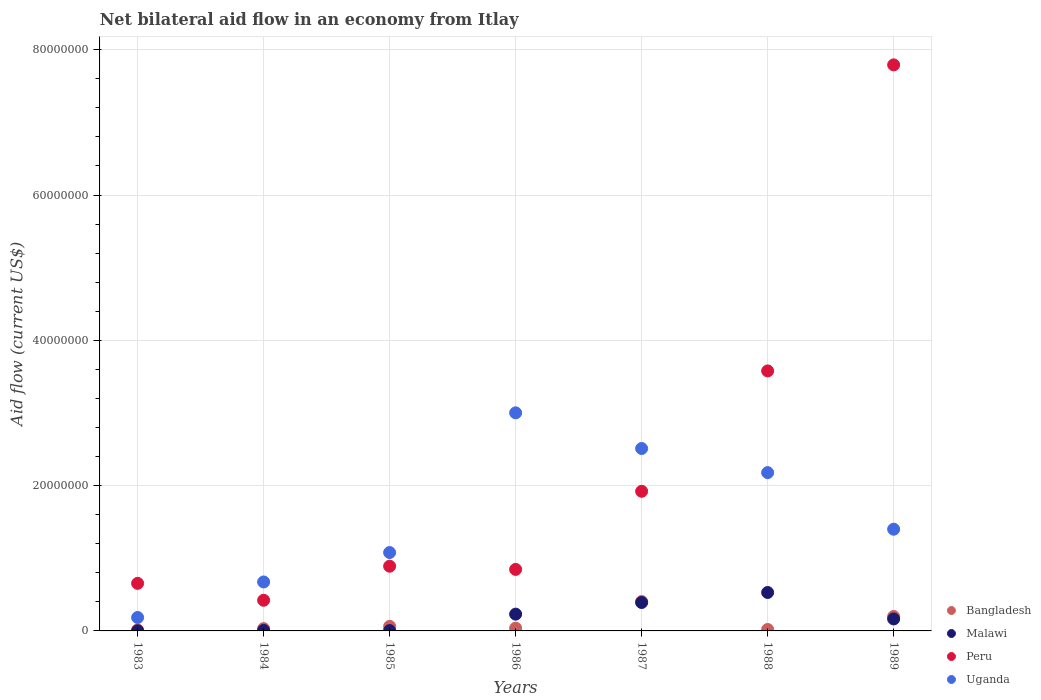How many different coloured dotlines are there?
Offer a very short reply. 4. Is the number of dotlines equal to the number of legend labels?
Make the answer very short. Yes. What is the net bilateral aid flow in Peru in 1987?
Offer a very short reply. 1.92e+07. Across all years, what is the maximum net bilateral aid flow in Malawi?
Ensure brevity in your answer.  5.29e+06. Across all years, what is the minimum net bilateral aid flow in Uganda?
Your answer should be compact. 1.85e+06. In which year was the net bilateral aid flow in Peru maximum?
Your answer should be compact. 1989. In which year was the net bilateral aid flow in Peru minimum?
Your answer should be compact. 1984. What is the total net bilateral aid flow in Uganda in the graph?
Your answer should be compact. 1.10e+08. What is the difference between the net bilateral aid flow in Malawi in 1983 and that in 1984?
Make the answer very short. -5.00e+04. What is the difference between the net bilateral aid flow in Peru in 1985 and the net bilateral aid flow in Bangladesh in 1987?
Your answer should be compact. 4.86e+06. What is the average net bilateral aid flow in Malawi per year?
Your response must be concise. 1.90e+06. In the year 1989, what is the difference between the net bilateral aid flow in Bangladesh and net bilateral aid flow in Malawi?
Your response must be concise. 3.40e+05. In how many years, is the net bilateral aid flow in Bangladesh greater than 56000000 US$?
Your answer should be very brief. 0. What is the ratio of the net bilateral aid flow in Bangladesh in 1985 to that in 1988?
Ensure brevity in your answer.  3.15. Is the difference between the net bilateral aid flow in Bangladesh in 1983 and 1987 greater than the difference between the net bilateral aid flow in Malawi in 1983 and 1987?
Offer a very short reply. No. What is the difference between the highest and the second highest net bilateral aid flow in Peru?
Offer a terse response. 4.21e+07. What is the difference between the highest and the lowest net bilateral aid flow in Malawi?
Offer a terse response. 5.27e+06. In how many years, is the net bilateral aid flow in Bangladesh greater than the average net bilateral aid flow in Bangladesh taken over all years?
Provide a succinct answer. 2. Is the sum of the net bilateral aid flow in Malawi in 1984 and 1985 greater than the maximum net bilateral aid flow in Bangladesh across all years?
Your answer should be very brief. No. Is it the case that in every year, the sum of the net bilateral aid flow in Malawi and net bilateral aid flow in Uganda  is greater than the net bilateral aid flow in Peru?
Your answer should be compact. No. Is the net bilateral aid flow in Bangladesh strictly greater than the net bilateral aid flow in Malawi over the years?
Provide a succinct answer. No. How many dotlines are there?
Offer a very short reply. 4. What is the difference between two consecutive major ticks on the Y-axis?
Offer a very short reply. 2.00e+07. Are the values on the major ticks of Y-axis written in scientific E-notation?
Offer a terse response. No. Does the graph contain grids?
Keep it short and to the point. Yes. How many legend labels are there?
Offer a very short reply. 4. How are the legend labels stacked?
Ensure brevity in your answer.  Vertical. What is the title of the graph?
Provide a succinct answer. Net bilateral aid flow in an economy from Itlay. Does "St. Vincent and the Grenadines" appear as one of the legend labels in the graph?
Provide a succinct answer. No. What is the label or title of the X-axis?
Your response must be concise. Years. What is the Aid flow (current US$) in Malawi in 1983?
Provide a short and direct response. 2.00e+04. What is the Aid flow (current US$) of Peru in 1983?
Your response must be concise. 6.55e+06. What is the Aid flow (current US$) in Uganda in 1983?
Your response must be concise. 1.85e+06. What is the Aid flow (current US$) of Bangladesh in 1984?
Offer a terse response. 3.20e+05. What is the Aid flow (current US$) of Peru in 1984?
Give a very brief answer. 4.22e+06. What is the Aid flow (current US$) in Uganda in 1984?
Ensure brevity in your answer.  6.74e+06. What is the Aid flow (current US$) of Bangladesh in 1985?
Offer a terse response. 6.30e+05. What is the Aid flow (current US$) in Peru in 1985?
Your answer should be very brief. 8.91e+06. What is the Aid flow (current US$) in Uganda in 1985?
Your answer should be very brief. 1.08e+07. What is the Aid flow (current US$) of Malawi in 1986?
Offer a very short reply. 2.31e+06. What is the Aid flow (current US$) of Peru in 1986?
Your answer should be very brief. 8.47e+06. What is the Aid flow (current US$) of Uganda in 1986?
Give a very brief answer. 3.00e+07. What is the Aid flow (current US$) of Bangladesh in 1987?
Give a very brief answer. 4.05e+06. What is the Aid flow (current US$) of Malawi in 1987?
Offer a very short reply. 3.91e+06. What is the Aid flow (current US$) of Peru in 1987?
Offer a terse response. 1.92e+07. What is the Aid flow (current US$) in Uganda in 1987?
Offer a terse response. 2.51e+07. What is the Aid flow (current US$) in Bangladesh in 1988?
Ensure brevity in your answer.  2.00e+05. What is the Aid flow (current US$) in Malawi in 1988?
Your answer should be compact. 5.29e+06. What is the Aid flow (current US$) of Peru in 1988?
Provide a succinct answer. 3.58e+07. What is the Aid flow (current US$) of Uganda in 1988?
Keep it short and to the point. 2.18e+07. What is the Aid flow (current US$) of Bangladesh in 1989?
Offer a very short reply. 1.99e+06. What is the Aid flow (current US$) in Malawi in 1989?
Provide a succinct answer. 1.65e+06. What is the Aid flow (current US$) in Peru in 1989?
Offer a terse response. 7.79e+07. What is the Aid flow (current US$) of Uganda in 1989?
Provide a succinct answer. 1.40e+07. Across all years, what is the maximum Aid flow (current US$) of Bangladesh?
Provide a succinct answer. 4.05e+06. Across all years, what is the maximum Aid flow (current US$) of Malawi?
Make the answer very short. 5.29e+06. Across all years, what is the maximum Aid flow (current US$) of Peru?
Offer a terse response. 7.79e+07. Across all years, what is the maximum Aid flow (current US$) of Uganda?
Your answer should be compact. 3.00e+07. Across all years, what is the minimum Aid flow (current US$) in Bangladesh?
Provide a succinct answer. 1.30e+05. Across all years, what is the minimum Aid flow (current US$) in Malawi?
Offer a terse response. 2.00e+04. Across all years, what is the minimum Aid flow (current US$) in Peru?
Offer a very short reply. 4.22e+06. Across all years, what is the minimum Aid flow (current US$) of Uganda?
Make the answer very short. 1.85e+06. What is the total Aid flow (current US$) in Bangladesh in the graph?
Ensure brevity in your answer.  7.70e+06. What is the total Aid flow (current US$) in Malawi in the graph?
Your response must be concise. 1.33e+07. What is the total Aid flow (current US$) in Peru in the graph?
Offer a very short reply. 1.61e+08. What is the total Aid flow (current US$) of Uganda in the graph?
Provide a succinct answer. 1.10e+08. What is the difference between the Aid flow (current US$) in Bangladesh in 1983 and that in 1984?
Keep it short and to the point. -1.90e+05. What is the difference between the Aid flow (current US$) in Malawi in 1983 and that in 1984?
Your response must be concise. -5.00e+04. What is the difference between the Aid flow (current US$) of Peru in 1983 and that in 1984?
Provide a succinct answer. 2.33e+06. What is the difference between the Aid flow (current US$) in Uganda in 1983 and that in 1984?
Offer a terse response. -4.89e+06. What is the difference between the Aid flow (current US$) in Bangladesh in 1983 and that in 1985?
Make the answer very short. -5.00e+05. What is the difference between the Aid flow (current US$) in Peru in 1983 and that in 1985?
Offer a terse response. -2.36e+06. What is the difference between the Aid flow (current US$) in Uganda in 1983 and that in 1985?
Provide a succinct answer. -8.94e+06. What is the difference between the Aid flow (current US$) in Malawi in 1983 and that in 1986?
Give a very brief answer. -2.29e+06. What is the difference between the Aid flow (current US$) in Peru in 1983 and that in 1986?
Provide a short and direct response. -1.92e+06. What is the difference between the Aid flow (current US$) in Uganda in 1983 and that in 1986?
Give a very brief answer. -2.82e+07. What is the difference between the Aid flow (current US$) in Bangladesh in 1983 and that in 1987?
Ensure brevity in your answer.  -3.92e+06. What is the difference between the Aid flow (current US$) of Malawi in 1983 and that in 1987?
Offer a very short reply. -3.89e+06. What is the difference between the Aid flow (current US$) of Peru in 1983 and that in 1987?
Offer a very short reply. -1.27e+07. What is the difference between the Aid flow (current US$) of Uganda in 1983 and that in 1987?
Your answer should be compact. -2.33e+07. What is the difference between the Aid flow (current US$) in Bangladesh in 1983 and that in 1988?
Provide a short and direct response. -7.00e+04. What is the difference between the Aid flow (current US$) in Malawi in 1983 and that in 1988?
Provide a short and direct response. -5.27e+06. What is the difference between the Aid flow (current US$) in Peru in 1983 and that in 1988?
Provide a succinct answer. -2.92e+07. What is the difference between the Aid flow (current US$) in Uganda in 1983 and that in 1988?
Offer a terse response. -1.99e+07. What is the difference between the Aid flow (current US$) of Bangladesh in 1983 and that in 1989?
Your response must be concise. -1.86e+06. What is the difference between the Aid flow (current US$) of Malawi in 1983 and that in 1989?
Provide a short and direct response. -1.63e+06. What is the difference between the Aid flow (current US$) of Peru in 1983 and that in 1989?
Ensure brevity in your answer.  -7.14e+07. What is the difference between the Aid flow (current US$) in Uganda in 1983 and that in 1989?
Make the answer very short. -1.22e+07. What is the difference between the Aid flow (current US$) in Bangladesh in 1984 and that in 1985?
Your answer should be compact. -3.10e+05. What is the difference between the Aid flow (current US$) in Peru in 1984 and that in 1985?
Keep it short and to the point. -4.69e+06. What is the difference between the Aid flow (current US$) in Uganda in 1984 and that in 1985?
Your answer should be compact. -4.05e+06. What is the difference between the Aid flow (current US$) in Bangladesh in 1984 and that in 1986?
Offer a very short reply. -6.00e+04. What is the difference between the Aid flow (current US$) in Malawi in 1984 and that in 1986?
Your answer should be very brief. -2.24e+06. What is the difference between the Aid flow (current US$) in Peru in 1984 and that in 1986?
Keep it short and to the point. -4.25e+06. What is the difference between the Aid flow (current US$) in Uganda in 1984 and that in 1986?
Offer a very short reply. -2.33e+07. What is the difference between the Aid flow (current US$) of Bangladesh in 1984 and that in 1987?
Your answer should be very brief. -3.73e+06. What is the difference between the Aid flow (current US$) of Malawi in 1984 and that in 1987?
Your answer should be compact. -3.84e+06. What is the difference between the Aid flow (current US$) of Peru in 1984 and that in 1987?
Give a very brief answer. -1.50e+07. What is the difference between the Aid flow (current US$) of Uganda in 1984 and that in 1987?
Provide a succinct answer. -1.84e+07. What is the difference between the Aid flow (current US$) in Malawi in 1984 and that in 1988?
Your response must be concise. -5.22e+06. What is the difference between the Aid flow (current US$) in Peru in 1984 and that in 1988?
Give a very brief answer. -3.16e+07. What is the difference between the Aid flow (current US$) in Uganda in 1984 and that in 1988?
Your answer should be very brief. -1.50e+07. What is the difference between the Aid flow (current US$) of Bangladesh in 1984 and that in 1989?
Make the answer very short. -1.67e+06. What is the difference between the Aid flow (current US$) in Malawi in 1984 and that in 1989?
Provide a short and direct response. -1.58e+06. What is the difference between the Aid flow (current US$) of Peru in 1984 and that in 1989?
Provide a short and direct response. -7.37e+07. What is the difference between the Aid flow (current US$) in Uganda in 1984 and that in 1989?
Provide a short and direct response. -7.26e+06. What is the difference between the Aid flow (current US$) of Malawi in 1985 and that in 1986?
Provide a succinct answer. -2.26e+06. What is the difference between the Aid flow (current US$) in Uganda in 1985 and that in 1986?
Provide a succinct answer. -1.92e+07. What is the difference between the Aid flow (current US$) in Bangladesh in 1985 and that in 1987?
Your answer should be compact. -3.42e+06. What is the difference between the Aid flow (current US$) in Malawi in 1985 and that in 1987?
Make the answer very short. -3.86e+06. What is the difference between the Aid flow (current US$) of Peru in 1985 and that in 1987?
Your answer should be very brief. -1.03e+07. What is the difference between the Aid flow (current US$) in Uganda in 1985 and that in 1987?
Offer a very short reply. -1.43e+07. What is the difference between the Aid flow (current US$) of Bangladesh in 1985 and that in 1988?
Provide a short and direct response. 4.30e+05. What is the difference between the Aid flow (current US$) of Malawi in 1985 and that in 1988?
Give a very brief answer. -5.24e+06. What is the difference between the Aid flow (current US$) in Peru in 1985 and that in 1988?
Provide a succinct answer. -2.69e+07. What is the difference between the Aid flow (current US$) in Uganda in 1985 and that in 1988?
Give a very brief answer. -1.10e+07. What is the difference between the Aid flow (current US$) in Bangladesh in 1985 and that in 1989?
Ensure brevity in your answer.  -1.36e+06. What is the difference between the Aid flow (current US$) of Malawi in 1985 and that in 1989?
Your response must be concise. -1.60e+06. What is the difference between the Aid flow (current US$) of Peru in 1985 and that in 1989?
Your response must be concise. -6.90e+07. What is the difference between the Aid flow (current US$) of Uganda in 1985 and that in 1989?
Provide a succinct answer. -3.21e+06. What is the difference between the Aid flow (current US$) of Bangladesh in 1986 and that in 1987?
Make the answer very short. -3.67e+06. What is the difference between the Aid flow (current US$) in Malawi in 1986 and that in 1987?
Ensure brevity in your answer.  -1.60e+06. What is the difference between the Aid flow (current US$) of Peru in 1986 and that in 1987?
Your answer should be very brief. -1.08e+07. What is the difference between the Aid flow (current US$) in Uganda in 1986 and that in 1987?
Ensure brevity in your answer.  4.91e+06. What is the difference between the Aid flow (current US$) of Malawi in 1986 and that in 1988?
Provide a short and direct response. -2.98e+06. What is the difference between the Aid flow (current US$) of Peru in 1986 and that in 1988?
Provide a short and direct response. -2.73e+07. What is the difference between the Aid flow (current US$) of Uganda in 1986 and that in 1988?
Provide a succinct answer. 8.23e+06. What is the difference between the Aid flow (current US$) of Bangladesh in 1986 and that in 1989?
Your response must be concise. -1.61e+06. What is the difference between the Aid flow (current US$) of Malawi in 1986 and that in 1989?
Make the answer very short. 6.60e+05. What is the difference between the Aid flow (current US$) in Peru in 1986 and that in 1989?
Your answer should be very brief. -6.94e+07. What is the difference between the Aid flow (current US$) in Uganda in 1986 and that in 1989?
Your answer should be compact. 1.60e+07. What is the difference between the Aid flow (current US$) in Bangladesh in 1987 and that in 1988?
Give a very brief answer. 3.85e+06. What is the difference between the Aid flow (current US$) of Malawi in 1987 and that in 1988?
Give a very brief answer. -1.38e+06. What is the difference between the Aid flow (current US$) of Peru in 1987 and that in 1988?
Keep it short and to the point. -1.66e+07. What is the difference between the Aid flow (current US$) in Uganda in 1987 and that in 1988?
Your response must be concise. 3.32e+06. What is the difference between the Aid flow (current US$) in Bangladesh in 1987 and that in 1989?
Offer a very short reply. 2.06e+06. What is the difference between the Aid flow (current US$) in Malawi in 1987 and that in 1989?
Your answer should be very brief. 2.26e+06. What is the difference between the Aid flow (current US$) in Peru in 1987 and that in 1989?
Your answer should be compact. -5.87e+07. What is the difference between the Aid flow (current US$) in Uganda in 1987 and that in 1989?
Keep it short and to the point. 1.11e+07. What is the difference between the Aid flow (current US$) in Bangladesh in 1988 and that in 1989?
Ensure brevity in your answer.  -1.79e+06. What is the difference between the Aid flow (current US$) of Malawi in 1988 and that in 1989?
Your response must be concise. 3.64e+06. What is the difference between the Aid flow (current US$) of Peru in 1988 and that in 1989?
Keep it short and to the point. -4.21e+07. What is the difference between the Aid flow (current US$) of Uganda in 1988 and that in 1989?
Provide a succinct answer. 7.79e+06. What is the difference between the Aid flow (current US$) of Bangladesh in 1983 and the Aid flow (current US$) of Peru in 1984?
Your response must be concise. -4.09e+06. What is the difference between the Aid flow (current US$) in Bangladesh in 1983 and the Aid flow (current US$) in Uganda in 1984?
Give a very brief answer. -6.61e+06. What is the difference between the Aid flow (current US$) in Malawi in 1983 and the Aid flow (current US$) in Peru in 1984?
Give a very brief answer. -4.20e+06. What is the difference between the Aid flow (current US$) of Malawi in 1983 and the Aid flow (current US$) of Uganda in 1984?
Make the answer very short. -6.72e+06. What is the difference between the Aid flow (current US$) in Bangladesh in 1983 and the Aid flow (current US$) in Peru in 1985?
Ensure brevity in your answer.  -8.78e+06. What is the difference between the Aid flow (current US$) of Bangladesh in 1983 and the Aid flow (current US$) of Uganda in 1985?
Provide a succinct answer. -1.07e+07. What is the difference between the Aid flow (current US$) of Malawi in 1983 and the Aid flow (current US$) of Peru in 1985?
Your answer should be compact. -8.89e+06. What is the difference between the Aid flow (current US$) of Malawi in 1983 and the Aid flow (current US$) of Uganda in 1985?
Your answer should be compact. -1.08e+07. What is the difference between the Aid flow (current US$) in Peru in 1983 and the Aid flow (current US$) in Uganda in 1985?
Your response must be concise. -4.24e+06. What is the difference between the Aid flow (current US$) in Bangladesh in 1983 and the Aid flow (current US$) in Malawi in 1986?
Provide a short and direct response. -2.18e+06. What is the difference between the Aid flow (current US$) in Bangladesh in 1983 and the Aid flow (current US$) in Peru in 1986?
Offer a very short reply. -8.34e+06. What is the difference between the Aid flow (current US$) of Bangladesh in 1983 and the Aid flow (current US$) of Uganda in 1986?
Your answer should be very brief. -2.99e+07. What is the difference between the Aid flow (current US$) of Malawi in 1983 and the Aid flow (current US$) of Peru in 1986?
Your response must be concise. -8.45e+06. What is the difference between the Aid flow (current US$) in Malawi in 1983 and the Aid flow (current US$) in Uganda in 1986?
Your answer should be very brief. -3.00e+07. What is the difference between the Aid flow (current US$) of Peru in 1983 and the Aid flow (current US$) of Uganda in 1986?
Ensure brevity in your answer.  -2.35e+07. What is the difference between the Aid flow (current US$) in Bangladesh in 1983 and the Aid flow (current US$) in Malawi in 1987?
Keep it short and to the point. -3.78e+06. What is the difference between the Aid flow (current US$) in Bangladesh in 1983 and the Aid flow (current US$) in Peru in 1987?
Give a very brief answer. -1.91e+07. What is the difference between the Aid flow (current US$) in Bangladesh in 1983 and the Aid flow (current US$) in Uganda in 1987?
Ensure brevity in your answer.  -2.50e+07. What is the difference between the Aid flow (current US$) of Malawi in 1983 and the Aid flow (current US$) of Peru in 1987?
Your answer should be compact. -1.92e+07. What is the difference between the Aid flow (current US$) of Malawi in 1983 and the Aid flow (current US$) of Uganda in 1987?
Offer a terse response. -2.51e+07. What is the difference between the Aid flow (current US$) in Peru in 1983 and the Aid flow (current US$) in Uganda in 1987?
Your response must be concise. -1.86e+07. What is the difference between the Aid flow (current US$) of Bangladesh in 1983 and the Aid flow (current US$) of Malawi in 1988?
Your answer should be compact. -5.16e+06. What is the difference between the Aid flow (current US$) in Bangladesh in 1983 and the Aid flow (current US$) in Peru in 1988?
Make the answer very short. -3.57e+07. What is the difference between the Aid flow (current US$) of Bangladesh in 1983 and the Aid flow (current US$) of Uganda in 1988?
Provide a succinct answer. -2.17e+07. What is the difference between the Aid flow (current US$) of Malawi in 1983 and the Aid flow (current US$) of Peru in 1988?
Keep it short and to the point. -3.58e+07. What is the difference between the Aid flow (current US$) in Malawi in 1983 and the Aid flow (current US$) in Uganda in 1988?
Your answer should be very brief. -2.18e+07. What is the difference between the Aid flow (current US$) in Peru in 1983 and the Aid flow (current US$) in Uganda in 1988?
Your answer should be compact. -1.52e+07. What is the difference between the Aid flow (current US$) in Bangladesh in 1983 and the Aid flow (current US$) in Malawi in 1989?
Offer a terse response. -1.52e+06. What is the difference between the Aid flow (current US$) of Bangladesh in 1983 and the Aid flow (current US$) of Peru in 1989?
Make the answer very short. -7.78e+07. What is the difference between the Aid flow (current US$) in Bangladesh in 1983 and the Aid flow (current US$) in Uganda in 1989?
Your answer should be very brief. -1.39e+07. What is the difference between the Aid flow (current US$) of Malawi in 1983 and the Aid flow (current US$) of Peru in 1989?
Your answer should be compact. -7.79e+07. What is the difference between the Aid flow (current US$) of Malawi in 1983 and the Aid flow (current US$) of Uganda in 1989?
Offer a very short reply. -1.40e+07. What is the difference between the Aid flow (current US$) of Peru in 1983 and the Aid flow (current US$) of Uganda in 1989?
Your answer should be very brief. -7.45e+06. What is the difference between the Aid flow (current US$) of Bangladesh in 1984 and the Aid flow (current US$) of Peru in 1985?
Provide a short and direct response. -8.59e+06. What is the difference between the Aid flow (current US$) in Bangladesh in 1984 and the Aid flow (current US$) in Uganda in 1985?
Offer a very short reply. -1.05e+07. What is the difference between the Aid flow (current US$) in Malawi in 1984 and the Aid flow (current US$) in Peru in 1985?
Your response must be concise. -8.84e+06. What is the difference between the Aid flow (current US$) of Malawi in 1984 and the Aid flow (current US$) of Uganda in 1985?
Provide a short and direct response. -1.07e+07. What is the difference between the Aid flow (current US$) of Peru in 1984 and the Aid flow (current US$) of Uganda in 1985?
Provide a short and direct response. -6.57e+06. What is the difference between the Aid flow (current US$) in Bangladesh in 1984 and the Aid flow (current US$) in Malawi in 1986?
Provide a succinct answer. -1.99e+06. What is the difference between the Aid flow (current US$) in Bangladesh in 1984 and the Aid flow (current US$) in Peru in 1986?
Your answer should be compact. -8.15e+06. What is the difference between the Aid flow (current US$) of Bangladesh in 1984 and the Aid flow (current US$) of Uganda in 1986?
Offer a terse response. -2.97e+07. What is the difference between the Aid flow (current US$) in Malawi in 1984 and the Aid flow (current US$) in Peru in 1986?
Give a very brief answer. -8.40e+06. What is the difference between the Aid flow (current US$) in Malawi in 1984 and the Aid flow (current US$) in Uganda in 1986?
Ensure brevity in your answer.  -3.00e+07. What is the difference between the Aid flow (current US$) in Peru in 1984 and the Aid flow (current US$) in Uganda in 1986?
Offer a terse response. -2.58e+07. What is the difference between the Aid flow (current US$) of Bangladesh in 1984 and the Aid flow (current US$) of Malawi in 1987?
Keep it short and to the point. -3.59e+06. What is the difference between the Aid flow (current US$) of Bangladesh in 1984 and the Aid flow (current US$) of Peru in 1987?
Keep it short and to the point. -1.89e+07. What is the difference between the Aid flow (current US$) in Bangladesh in 1984 and the Aid flow (current US$) in Uganda in 1987?
Your answer should be compact. -2.48e+07. What is the difference between the Aid flow (current US$) of Malawi in 1984 and the Aid flow (current US$) of Peru in 1987?
Ensure brevity in your answer.  -1.92e+07. What is the difference between the Aid flow (current US$) of Malawi in 1984 and the Aid flow (current US$) of Uganda in 1987?
Provide a succinct answer. -2.50e+07. What is the difference between the Aid flow (current US$) of Peru in 1984 and the Aid flow (current US$) of Uganda in 1987?
Your answer should be compact. -2.09e+07. What is the difference between the Aid flow (current US$) of Bangladesh in 1984 and the Aid flow (current US$) of Malawi in 1988?
Provide a succinct answer. -4.97e+06. What is the difference between the Aid flow (current US$) in Bangladesh in 1984 and the Aid flow (current US$) in Peru in 1988?
Offer a very short reply. -3.55e+07. What is the difference between the Aid flow (current US$) of Bangladesh in 1984 and the Aid flow (current US$) of Uganda in 1988?
Your response must be concise. -2.15e+07. What is the difference between the Aid flow (current US$) in Malawi in 1984 and the Aid flow (current US$) in Peru in 1988?
Offer a terse response. -3.57e+07. What is the difference between the Aid flow (current US$) of Malawi in 1984 and the Aid flow (current US$) of Uganda in 1988?
Your answer should be very brief. -2.17e+07. What is the difference between the Aid flow (current US$) of Peru in 1984 and the Aid flow (current US$) of Uganda in 1988?
Your response must be concise. -1.76e+07. What is the difference between the Aid flow (current US$) in Bangladesh in 1984 and the Aid flow (current US$) in Malawi in 1989?
Give a very brief answer. -1.33e+06. What is the difference between the Aid flow (current US$) of Bangladesh in 1984 and the Aid flow (current US$) of Peru in 1989?
Provide a short and direct response. -7.76e+07. What is the difference between the Aid flow (current US$) in Bangladesh in 1984 and the Aid flow (current US$) in Uganda in 1989?
Offer a very short reply. -1.37e+07. What is the difference between the Aid flow (current US$) of Malawi in 1984 and the Aid flow (current US$) of Peru in 1989?
Your answer should be compact. -7.78e+07. What is the difference between the Aid flow (current US$) of Malawi in 1984 and the Aid flow (current US$) of Uganda in 1989?
Provide a short and direct response. -1.39e+07. What is the difference between the Aid flow (current US$) in Peru in 1984 and the Aid flow (current US$) in Uganda in 1989?
Make the answer very short. -9.78e+06. What is the difference between the Aid flow (current US$) of Bangladesh in 1985 and the Aid flow (current US$) of Malawi in 1986?
Offer a very short reply. -1.68e+06. What is the difference between the Aid flow (current US$) in Bangladesh in 1985 and the Aid flow (current US$) in Peru in 1986?
Your answer should be compact. -7.84e+06. What is the difference between the Aid flow (current US$) in Bangladesh in 1985 and the Aid flow (current US$) in Uganda in 1986?
Keep it short and to the point. -2.94e+07. What is the difference between the Aid flow (current US$) of Malawi in 1985 and the Aid flow (current US$) of Peru in 1986?
Make the answer very short. -8.42e+06. What is the difference between the Aid flow (current US$) in Malawi in 1985 and the Aid flow (current US$) in Uganda in 1986?
Your answer should be very brief. -3.00e+07. What is the difference between the Aid flow (current US$) in Peru in 1985 and the Aid flow (current US$) in Uganda in 1986?
Your answer should be compact. -2.11e+07. What is the difference between the Aid flow (current US$) of Bangladesh in 1985 and the Aid flow (current US$) of Malawi in 1987?
Ensure brevity in your answer.  -3.28e+06. What is the difference between the Aid flow (current US$) in Bangladesh in 1985 and the Aid flow (current US$) in Peru in 1987?
Offer a very short reply. -1.86e+07. What is the difference between the Aid flow (current US$) in Bangladesh in 1985 and the Aid flow (current US$) in Uganda in 1987?
Your response must be concise. -2.45e+07. What is the difference between the Aid flow (current US$) of Malawi in 1985 and the Aid flow (current US$) of Peru in 1987?
Provide a succinct answer. -1.92e+07. What is the difference between the Aid flow (current US$) in Malawi in 1985 and the Aid flow (current US$) in Uganda in 1987?
Provide a short and direct response. -2.51e+07. What is the difference between the Aid flow (current US$) of Peru in 1985 and the Aid flow (current US$) of Uganda in 1987?
Ensure brevity in your answer.  -1.62e+07. What is the difference between the Aid flow (current US$) in Bangladesh in 1985 and the Aid flow (current US$) in Malawi in 1988?
Keep it short and to the point. -4.66e+06. What is the difference between the Aid flow (current US$) in Bangladesh in 1985 and the Aid flow (current US$) in Peru in 1988?
Offer a terse response. -3.52e+07. What is the difference between the Aid flow (current US$) in Bangladesh in 1985 and the Aid flow (current US$) in Uganda in 1988?
Your answer should be compact. -2.12e+07. What is the difference between the Aid flow (current US$) of Malawi in 1985 and the Aid flow (current US$) of Peru in 1988?
Your answer should be very brief. -3.57e+07. What is the difference between the Aid flow (current US$) in Malawi in 1985 and the Aid flow (current US$) in Uganda in 1988?
Offer a terse response. -2.17e+07. What is the difference between the Aid flow (current US$) of Peru in 1985 and the Aid flow (current US$) of Uganda in 1988?
Keep it short and to the point. -1.29e+07. What is the difference between the Aid flow (current US$) in Bangladesh in 1985 and the Aid flow (current US$) in Malawi in 1989?
Offer a very short reply. -1.02e+06. What is the difference between the Aid flow (current US$) in Bangladesh in 1985 and the Aid flow (current US$) in Peru in 1989?
Provide a short and direct response. -7.73e+07. What is the difference between the Aid flow (current US$) in Bangladesh in 1985 and the Aid flow (current US$) in Uganda in 1989?
Make the answer very short. -1.34e+07. What is the difference between the Aid flow (current US$) of Malawi in 1985 and the Aid flow (current US$) of Peru in 1989?
Provide a succinct answer. -7.79e+07. What is the difference between the Aid flow (current US$) in Malawi in 1985 and the Aid flow (current US$) in Uganda in 1989?
Offer a terse response. -1.40e+07. What is the difference between the Aid flow (current US$) of Peru in 1985 and the Aid flow (current US$) of Uganda in 1989?
Provide a succinct answer. -5.09e+06. What is the difference between the Aid flow (current US$) of Bangladesh in 1986 and the Aid flow (current US$) of Malawi in 1987?
Provide a short and direct response. -3.53e+06. What is the difference between the Aid flow (current US$) of Bangladesh in 1986 and the Aid flow (current US$) of Peru in 1987?
Provide a short and direct response. -1.88e+07. What is the difference between the Aid flow (current US$) in Bangladesh in 1986 and the Aid flow (current US$) in Uganda in 1987?
Your answer should be compact. -2.47e+07. What is the difference between the Aid flow (current US$) in Malawi in 1986 and the Aid flow (current US$) in Peru in 1987?
Offer a very short reply. -1.69e+07. What is the difference between the Aid flow (current US$) of Malawi in 1986 and the Aid flow (current US$) of Uganda in 1987?
Make the answer very short. -2.28e+07. What is the difference between the Aid flow (current US$) of Peru in 1986 and the Aid flow (current US$) of Uganda in 1987?
Offer a very short reply. -1.66e+07. What is the difference between the Aid flow (current US$) of Bangladesh in 1986 and the Aid flow (current US$) of Malawi in 1988?
Keep it short and to the point. -4.91e+06. What is the difference between the Aid flow (current US$) of Bangladesh in 1986 and the Aid flow (current US$) of Peru in 1988?
Ensure brevity in your answer.  -3.54e+07. What is the difference between the Aid flow (current US$) of Bangladesh in 1986 and the Aid flow (current US$) of Uganda in 1988?
Give a very brief answer. -2.14e+07. What is the difference between the Aid flow (current US$) in Malawi in 1986 and the Aid flow (current US$) in Peru in 1988?
Your response must be concise. -3.35e+07. What is the difference between the Aid flow (current US$) in Malawi in 1986 and the Aid flow (current US$) in Uganda in 1988?
Your response must be concise. -1.95e+07. What is the difference between the Aid flow (current US$) of Peru in 1986 and the Aid flow (current US$) of Uganda in 1988?
Ensure brevity in your answer.  -1.33e+07. What is the difference between the Aid flow (current US$) in Bangladesh in 1986 and the Aid flow (current US$) in Malawi in 1989?
Ensure brevity in your answer.  -1.27e+06. What is the difference between the Aid flow (current US$) of Bangladesh in 1986 and the Aid flow (current US$) of Peru in 1989?
Your answer should be compact. -7.75e+07. What is the difference between the Aid flow (current US$) of Bangladesh in 1986 and the Aid flow (current US$) of Uganda in 1989?
Offer a terse response. -1.36e+07. What is the difference between the Aid flow (current US$) in Malawi in 1986 and the Aid flow (current US$) in Peru in 1989?
Provide a succinct answer. -7.56e+07. What is the difference between the Aid flow (current US$) of Malawi in 1986 and the Aid flow (current US$) of Uganda in 1989?
Provide a short and direct response. -1.17e+07. What is the difference between the Aid flow (current US$) in Peru in 1986 and the Aid flow (current US$) in Uganda in 1989?
Offer a very short reply. -5.53e+06. What is the difference between the Aid flow (current US$) of Bangladesh in 1987 and the Aid flow (current US$) of Malawi in 1988?
Offer a terse response. -1.24e+06. What is the difference between the Aid flow (current US$) in Bangladesh in 1987 and the Aid flow (current US$) in Peru in 1988?
Your answer should be compact. -3.17e+07. What is the difference between the Aid flow (current US$) of Bangladesh in 1987 and the Aid flow (current US$) of Uganda in 1988?
Give a very brief answer. -1.77e+07. What is the difference between the Aid flow (current US$) in Malawi in 1987 and the Aid flow (current US$) in Peru in 1988?
Your answer should be very brief. -3.19e+07. What is the difference between the Aid flow (current US$) of Malawi in 1987 and the Aid flow (current US$) of Uganda in 1988?
Keep it short and to the point. -1.79e+07. What is the difference between the Aid flow (current US$) of Peru in 1987 and the Aid flow (current US$) of Uganda in 1988?
Provide a short and direct response. -2.57e+06. What is the difference between the Aid flow (current US$) of Bangladesh in 1987 and the Aid flow (current US$) of Malawi in 1989?
Give a very brief answer. 2.40e+06. What is the difference between the Aid flow (current US$) of Bangladesh in 1987 and the Aid flow (current US$) of Peru in 1989?
Your answer should be compact. -7.39e+07. What is the difference between the Aid flow (current US$) in Bangladesh in 1987 and the Aid flow (current US$) in Uganda in 1989?
Your answer should be compact. -9.95e+06. What is the difference between the Aid flow (current US$) of Malawi in 1987 and the Aid flow (current US$) of Peru in 1989?
Offer a very short reply. -7.40e+07. What is the difference between the Aid flow (current US$) in Malawi in 1987 and the Aid flow (current US$) in Uganda in 1989?
Your answer should be compact. -1.01e+07. What is the difference between the Aid flow (current US$) in Peru in 1987 and the Aid flow (current US$) in Uganda in 1989?
Your answer should be compact. 5.22e+06. What is the difference between the Aid flow (current US$) in Bangladesh in 1988 and the Aid flow (current US$) in Malawi in 1989?
Offer a very short reply. -1.45e+06. What is the difference between the Aid flow (current US$) of Bangladesh in 1988 and the Aid flow (current US$) of Peru in 1989?
Keep it short and to the point. -7.77e+07. What is the difference between the Aid flow (current US$) in Bangladesh in 1988 and the Aid flow (current US$) in Uganda in 1989?
Offer a terse response. -1.38e+07. What is the difference between the Aid flow (current US$) in Malawi in 1988 and the Aid flow (current US$) in Peru in 1989?
Offer a terse response. -7.26e+07. What is the difference between the Aid flow (current US$) of Malawi in 1988 and the Aid flow (current US$) of Uganda in 1989?
Your answer should be very brief. -8.71e+06. What is the difference between the Aid flow (current US$) of Peru in 1988 and the Aid flow (current US$) of Uganda in 1989?
Provide a short and direct response. 2.18e+07. What is the average Aid flow (current US$) in Bangladesh per year?
Offer a terse response. 1.10e+06. What is the average Aid flow (current US$) in Malawi per year?
Give a very brief answer. 1.90e+06. What is the average Aid flow (current US$) of Peru per year?
Offer a very short reply. 2.30e+07. What is the average Aid flow (current US$) of Uganda per year?
Offer a very short reply. 1.58e+07. In the year 1983, what is the difference between the Aid flow (current US$) of Bangladesh and Aid flow (current US$) of Malawi?
Make the answer very short. 1.10e+05. In the year 1983, what is the difference between the Aid flow (current US$) in Bangladesh and Aid flow (current US$) in Peru?
Ensure brevity in your answer.  -6.42e+06. In the year 1983, what is the difference between the Aid flow (current US$) of Bangladesh and Aid flow (current US$) of Uganda?
Offer a terse response. -1.72e+06. In the year 1983, what is the difference between the Aid flow (current US$) in Malawi and Aid flow (current US$) in Peru?
Your answer should be very brief. -6.53e+06. In the year 1983, what is the difference between the Aid flow (current US$) in Malawi and Aid flow (current US$) in Uganda?
Keep it short and to the point. -1.83e+06. In the year 1983, what is the difference between the Aid flow (current US$) of Peru and Aid flow (current US$) of Uganda?
Your answer should be compact. 4.70e+06. In the year 1984, what is the difference between the Aid flow (current US$) of Bangladesh and Aid flow (current US$) of Peru?
Your answer should be very brief. -3.90e+06. In the year 1984, what is the difference between the Aid flow (current US$) of Bangladesh and Aid flow (current US$) of Uganda?
Your answer should be compact. -6.42e+06. In the year 1984, what is the difference between the Aid flow (current US$) in Malawi and Aid flow (current US$) in Peru?
Your answer should be very brief. -4.15e+06. In the year 1984, what is the difference between the Aid flow (current US$) in Malawi and Aid flow (current US$) in Uganda?
Make the answer very short. -6.67e+06. In the year 1984, what is the difference between the Aid flow (current US$) of Peru and Aid flow (current US$) of Uganda?
Make the answer very short. -2.52e+06. In the year 1985, what is the difference between the Aid flow (current US$) in Bangladesh and Aid flow (current US$) in Malawi?
Your answer should be very brief. 5.80e+05. In the year 1985, what is the difference between the Aid flow (current US$) in Bangladesh and Aid flow (current US$) in Peru?
Make the answer very short. -8.28e+06. In the year 1985, what is the difference between the Aid flow (current US$) in Bangladesh and Aid flow (current US$) in Uganda?
Your response must be concise. -1.02e+07. In the year 1985, what is the difference between the Aid flow (current US$) of Malawi and Aid flow (current US$) of Peru?
Your answer should be very brief. -8.86e+06. In the year 1985, what is the difference between the Aid flow (current US$) of Malawi and Aid flow (current US$) of Uganda?
Your answer should be compact. -1.07e+07. In the year 1985, what is the difference between the Aid flow (current US$) in Peru and Aid flow (current US$) in Uganda?
Keep it short and to the point. -1.88e+06. In the year 1986, what is the difference between the Aid flow (current US$) of Bangladesh and Aid flow (current US$) of Malawi?
Offer a terse response. -1.93e+06. In the year 1986, what is the difference between the Aid flow (current US$) in Bangladesh and Aid flow (current US$) in Peru?
Provide a short and direct response. -8.09e+06. In the year 1986, what is the difference between the Aid flow (current US$) in Bangladesh and Aid flow (current US$) in Uganda?
Keep it short and to the point. -2.96e+07. In the year 1986, what is the difference between the Aid flow (current US$) of Malawi and Aid flow (current US$) of Peru?
Your response must be concise. -6.16e+06. In the year 1986, what is the difference between the Aid flow (current US$) of Malawi and Aid flow (current US$) of Uganda?
Your answer should be compact. -2.77e+07. In the year 1986, what is the difference between the Aid flow (current US$) of Peru and Aid flow (current US$) of Uganda?
Keep it short and to the point. -2.16e+07. In the year 1987, what is the difference between the Aid flow (current US$) in Bangladesh and Aid flow (current US$) in Peru?
Offer a terse response. -1.52e+07. In the year 1987, what is the difference between the Aid flow (current US$) of Bangladesh and Aid flow (current US$) of Uganda?
Give a very brief answer. -2.11e+07. In the year 1987, what is the difference between the Aid flow (current US$) in Malawi and Aid flow (current US$) in Peru?
Provide a succinct answer. -1.53e+07. In the year 1987, what is the difference between the Aid flow (current US$) in Malawi and Aid flow (current US$) in Uganda?
Provide a short and direct response. -2.12e+07. In the year 1987, what is the difference between the Aid flow (current US$) in Peru and Aid flow (current US$) in Uganda?
Give a very brief answer. -5.89e+06. In the year 1988, what is the difference between the Aid flow (current US$) in Bangladesh and Aid flow (current US$) in Malawi?
Offer a very short reply. -5.09e+06. In the year 1988, what is the difference between the Aid flow (current US$) of Bangladesh and Aid flow (current US$) of Peru?
Make the answer very short. -3.56e+07. In the year 1988, what is the difference between the Aid flow (current US$) in Bangladesh and Aid flow (current US$) in Uganda?
Provide a succinct answer. -2.16e+07. In the year 1988, what is the difference between the Aid flow (current US$) in Malawi and Aid flow (current US$) in Peru?
Give a very brief answer. -3.05e+07. In the year 1988, what is the difference between the Aid flow (current US$) of Malawi and Aid flow (current US$) of Uganda?
Keep it short and to the point. -1.65e+07. In the year 1988, what is the difference between the Aid flow (current US$) of Peru and Aid flow (current US$) of Uganda?
Make the answer very short. 1.40e+07. In the year 1989, what is the difference between the Aid flow (current US$) in Bangladesh and Aid flow (current US$) in Malawi?
Provide a short and direct response. 3.40e+05. In the year 1989, what is the difference between the Aid flow (current US$) of Bangladesh and Aid flow (current US$) of Peru?
Offer a terse response. -7.59e+07. In the year 1989, what is the difference between the Aid flow (current US$) in Bangladesh and Aid flow (current US$) in Uganda?
Offer a very short reply. -1.20e+07. In the year 1989, what is the difference between the Aid flow (current US$) in Malawi and Aid flow (current US$) in Peru?
Offer a very short reply. -7.63e+07. In the year 1989, what is the difference between the Aid flow (current US$) in Malawi and Aid flow (current US$) in Uganda?
Offer a terse response. -1.24e+07. In the year 1989, what is the difference between the Aid flow (current US$) in Peru and Aid flow (current US$) in Uganda?
Make the answer very short. 6.39e+07. What is the ratio of the Aid flow (current US$) in Bangladesh in 1983 to that in 1984?
Ensure brevity in your answer.  0.41. What is the ratio of the Aid flow (current US$) in Malawi in 1983 to that in 1984?
Provide a succinct answer. 0.29. What is the ratio of the Aid flow (current US$) in Peru in 1983 to that in 1984?
Provide a short and direct response. 1.55. What is the ratio of the Aid flow (current US$) in Uganda in 1983 to that in 1984?
Your answer should be compact. 0.27. What is the ratio of the Aid flow (current US$) of Bangladesh in 1983 to that in 1985?
Provide a succinct answer. 0.21. What is the ratio of the Aid flow (current US$) of Peru in 1983 to that in 1985?
Ensure brevity in your answer.  0.74. What is the ratio of the Aid flow (current US$) of Uganda in 1983 to that in 1985?
Ensure brevity in your answer.  0.17. What is the ratio of the Aid flow (current US$) of Bangladesh in 1983 to that in 1986?
Offer a terse response. 0.34. What is the ratio of the Aid flow (current US$) in Malawi in 1983 to that in 1986?
Keep it short and to the point. 0.01. What is the ratio of the Aid flow (current US$) of Peru in 1983 to that in 1986?
Your answer should be compact. 0.77. What is the ratio of the Aid flow (current US$) of Uganda in 1983 to that in 1986?
Make the answer very short. 0.06. What is the ratio of the Aid flow (current US$) of Bangladesh in 1983 to that in 1987?
Your answer should be compact. 0.03. What is the ratio of the Aid flow (current US$) in Malawi in 1983 to that in 1987?
Keep it short and to the point. 0.01. What is the ratio of the Aid flow (current US$) in Peru in 1983 to that in 1987?
Your response must be concise. 0.34. What is the ratio of the Aid flow (current US$) in Uganda in 1983 to that in 1987?
Ensure brevity in your answer.  0.07. What is the ratio of the Aid flow (current US$) in Bangladesh in 1983 to that in 1988?
Your answer should be very brief. 0.65. What is the ratio of the Aid flow (current US$) of Malawi in 1983 to that in 1988?
Give a very brief answer. 0. What is the ratio of the Aid flow (current US$) of Peru in 1983 to that in 1988?
Offer a very short reply. 0.18. What is the ratio of the Aid flow (current US$) in Uganda in 1983 to that in 1988?
Keep it short and to the point. 0.08. What is the ratio of the Aid flow (current US$) in Bangladesh in 1983 to that in 1989?
Provide a short and direct response. 0.07. What is the ratio of the Aid flow (current US$) of Malawi in 1983 to that in 1989?
Your answer should be compact. 0.01. What is the ratio of the Aid flow (current US$) in Peru in 1983 to that in 1989?
Offer a terse response. 0.08. What is the ratio of the Aid flow (current US$) in Uganda in 1983 to that in 1989?
Provide a succinct answer. 0.13. What is the ratio of the Aid flow (current US$) of Bangladesh in 1984 to that in 1985?
Give a very brief answer. 0.51. What is the ratio of the Aid flow (current US$) in Malawi in 1984 to that in 1985?
Offer a terse response. 1.4. What is the ratio of the Aid flow (current US$) of Peru in 1984 to that in 1985?
Provide a short and direct response. 0.47. What is the ratio of the Aid flow (current US$) in Uganda in 1984 to that in 1985?
Your answer should be compact. 0.62. What is the ratio of the Aid flow (current US$) in Bangladesh in 1984 to that in 1986?
Your response must be concise. 0.84. What is the ratio of the Aid flow (current US$) of Malawi in 1984 to that in 1986?
Offer a very short reply. 0.03. What is the ratio of the Aid flow (current US$) in Peru in 1984 to that in 1986?
Offer a terse response. 0.5. What is the ratio of the Aid flow (current US$) of Uganda in 1984 to that in 1986?
Ensure brevity in your answer.  0.22. What is the ratio of the Aid flow (current US$) in Bangladesh in 1984 to that in 1987?
Provide a succinct answer. 0.08. What is the ratio of the Aid flow (current US$) of Malawi in 1984 to that in 1987?
Provide a short and direct response. 0.02. What is the ratio of the Aid flow (current US$) in Peru in 1984 to that in 1987?
Give a very brief answer. 0.22. What is the ratio of the Aid flow (current US$) of Uganda in 1984 to that in 1987?
Give a very brief answer. 0.27. What is the ratio of the Aid flow (current US$) in Malawi in 1984 to that in 1988?
Your response must be concise. 0.01. What is the ratio of the Aid flow (current US$) of Peru in 1984 to that in 1988?
Provide a succinct answer. 0.12. What is the ratio of the Aid flow (current US$) in Uganda in 1984 to that in 1988?
Keep it short and to the point. 0.31. What is the ratio of the Aid flow (current US$) in Bangladesh in 1984 to that in 1989?
Offer a very short reply. 0.16. What is the ratio of the Aid flow (current US$) of Malawi in 1984 to that in 1989?
Provide a succinct answer. 0.04. What is the ratio of the Aid flow (current US$) in Peru in 1984 to that in 1989?
Your response must be concise. 0.05. What is the ratio of the Aid flow (current US$) of Uganda in 1984 to that in 1989?
Your answer should be compact. 0.48. What is the ratio of the Aid flow (current US$) in Bangladesh in 1985 to that in 1986?
Your answer should be very brief. 1.66. What is the ratio of the Aid flow (current US$) of Malawi in 1985 to that in 1986?
Give a very brief answer. 0.02. What is the ratio of the Aid flow (current US$) of Peru in 1985 to that in 1986?
Your answer should be compact. 1.05. What is the ratio of the Aid flow (current US$) of Uganda in 1985 to that in 1986?
Your answer should be compact. 0.36. What is the ratio of the Aid flow (current US$) of Bangladesh in 1985 to that in 1987?
Keep it short and to the point. 0.16. What is the ratio of the Aid flow (current US$) in Malawi in 1985 to that in 1987?
Make the answer very short. 0.01. What is the ratio of the Aid flow (current US$) in Peru in 1985 to that in 1987?
Keep it short and to the point. 0.46. What is the ratio of the Aid flow (current US$) in Uganda in 1985 to that in 1987?
Make the answer very short. 0.43. What is the ratio of the Aid flow (current US$) of Bangladesh in 1985 to that in 1988?
Give a very brief answer. 3.15. What is the ratio of the Aid flow (current US$) of Malawi in 1985 to that in 1988?
Make the answer very short. 0.01. What is the ratio of the Aid flow (current US$) of Peru in 1985 to that in 1988?
Make the answer very short. 0.25. What is the ratio of the Aid flow (current US$) in Uganda in 1985 to that in 1988?
Your response must be concise. 0.5. What is the ratio of the Aid flow (current US$) of Bangladesh in 1985 to that in 1989?
Give a very brief answer. 0.32. What is the ratio of the Aid flow (current US$) in Malawi in 1985 to that in 1989?
Make the answer very short. 0.03. What is the ratio of the Aid flow (current US$) in Peru in 1985 to that in 1989?
Provide a short and direct response. 0.11. What is the ratio of the Aid flow (current US$) of Uganda in 1985 to that in 1989?
Make the answer very short. 0.77. What is the ratio of the Aid flow (current US$) in Bangladesh in 1986 to that in 1987?
Keep it short and to the point. 0.09. What is the ratio of the Aid flow (current US$) of Malawi in 1986 to that in 1987?
Your response must be concise. 0.59. What is the ratio of the Aid flow (current US$) in Peru in 1986 to that in 1987?
Make the answer very short. 0.44. What is the ratio of the Aid flow (current US$) of Uganda in 1986 to that in 1987?
Ensure brevity in your answer.  1.2. What is the ratio of the Aid flow (current US$) in Malawi in 1986 to that in 1988?
Provide a succinct answer. 0.44. What is the ratio of the Aid flow (current US$) of Peru in 1986 to that in 1988?
Your response must be concise. 0.24. What is the ratio of the Aid flow (current US$) in Uganda in 1986 to that in 1988?
Provide a short and direct response. 1.38. What is the ratio of the Aid flow (current US$) in Bangladesh in 1986 to that in 1989?
Provide a succinct answer. 0.19. What is the ratio of the Aid flow (current US$) in Malawi in 1986 to that in 1989?
Offer a very short reply. 1.4. What is the ratio of the Aid flow (current US$) in Peru in 1986 to that in 1989?
Your answer should be compact. 0.11. What is the ratio of the Aid flow (current US$) in Uganda in 1986 to that in 1989?
Provide a succinct answer. 2.14. What is the ratio of the Aid flow (current US$) of Bangladesh in 1987 to that in 1988?
Ensure brevity in your answer.  20.25. What is the ratio of the Aid flow (current US$) in Malawi in 1987 to that in 1988?
Offer a terse response. 0.74. What is the ratio of the Aid flow (current US$) in Peru in 1987 to that in 1988?
Ensure brevity in your answer.  0.54. What is the ratio of the Aid flow (current US$) of Uganda in 1987 to that in 1988?
Offer a very short reply. 1.15. What is the ratio of the Aid flow (current US$) of Bangladesh in 1987 to that in 1989?
Keep it short and to the point. 2.04. What is the ratio of the Aid flow (current US$) of Malawi in 1987 to that in 1989?
Give a very brief answer. 2.37. What is the ratio of the Aid flow (current US$) of Peru in 1987 to that in 1989?
Offer a very short reply. 0.25. What is the ratio of the Aid flow (current US$) of Uganda in 1987 to that in 1989?
Offer a terse response. 1.79. What is the ratio of the Aid flow (current US$) in Bangladesh in 1988 to that in 1989?
Your response must be concise. 0.1. What is the ratio of the Aid flow (current US$) in Malawi in 1988 to that in 1989?
Provide a succinct answer. 3.21. What is the ratio of the Aid flow (current US$) of Peru in 1988 to that in 1989?
Your response must be concise. 0.46. What is the ratio of the Aid flow (current US$) in Uganda in 1988 to that in 1989?
Your answer should be very brief. 1.56. What is the difference between the highest and the second highest Aid flow (current US$) in Bangladesh?
Give a very brief answer. 2.06e+06. What is the difference between the highest and the second highest Aid flow (current US$) of Malawi?
Make the answer very short. 1.38e+06. What is the difference between the highest and the second highest Aid flow (current US$) in Peru?
Your answer should be compact. 4.21e+07. What is the difference between the highest and the second highest Aid flow (current US$) in Uganda?
Offer a very short reply. 4.91e+06. What is the difference between the highest and the lowest Aid flow (current US$) in Bangladesh?
Your response must be concise. 3.92e+06. What is the difference between the highest and the lowest Aid flow (current US$) in Malawi?
Your response must be concise. 5.27e+06. What is the difference between the highest and the lowest Aid flow (current US$) of Peru?
Your answer should be compact. 7.37e+07. What is the difference between the highest and the lowest Aid flow (current US$) in Uganda?
Provide a succinct answer. 2.82e+07. 